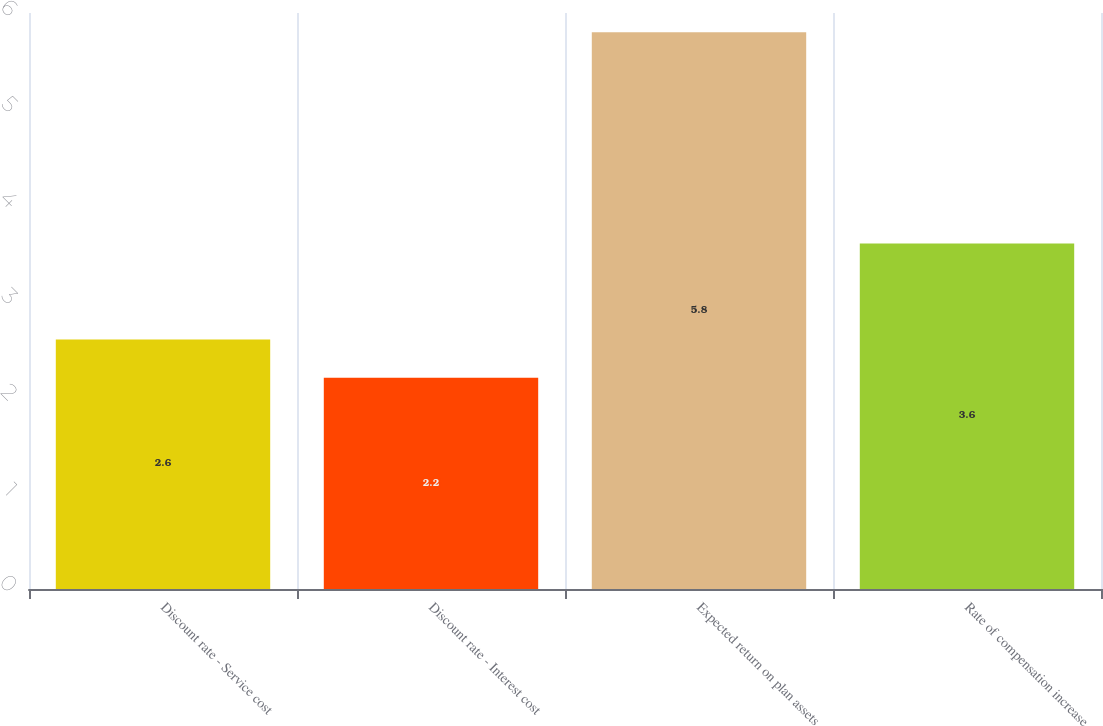<chart> <loc_0><loc_0><loc_500><loc_500><bar_chart><fcel>Discount rate - Service cost<fcel>Discount rate - Interest cost<fcel>Expected return on plan assets<fcel>Rate of compensation increase<nl><fcel>2.6<fcel>2.2<fcel>5.8<fcel>3.6<nl></chart> 